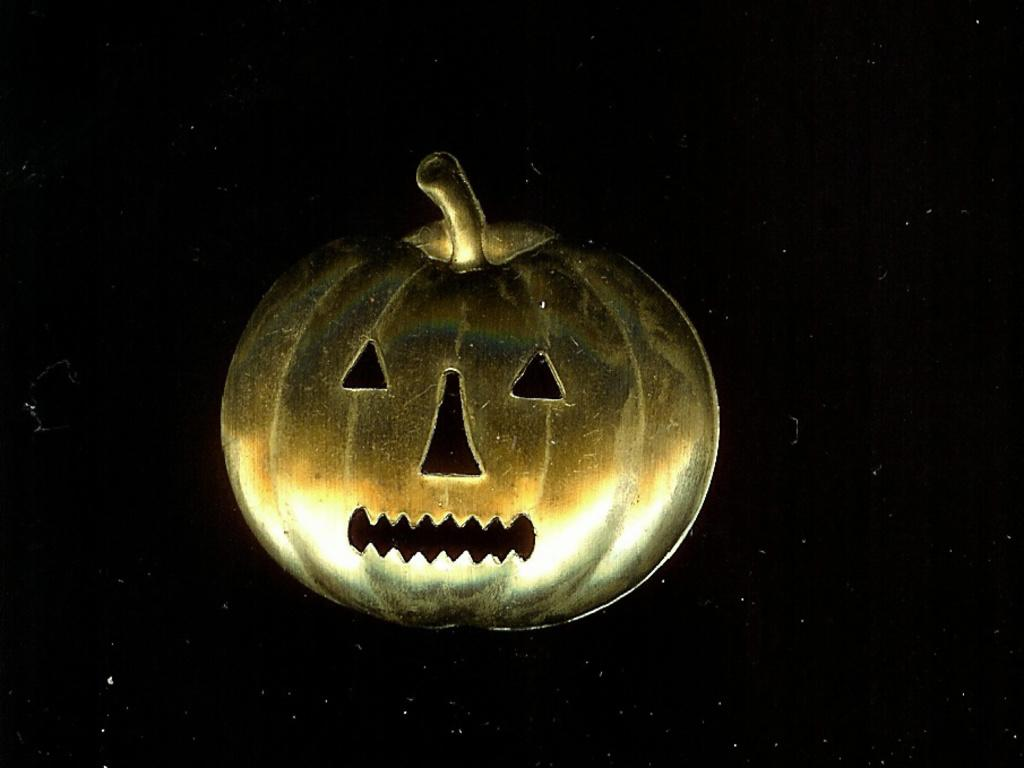What is the main subject of the image? There is a depiction of a pumpkin in the center of the image. Can you describe the appearance of the pumpkin? The provided facts do not include a description of the pumpkin's appearance. What might be the purpose of the image? The purpose of the image is not specified in the provided facts. What is the result of 2 + 2 in the image? There is no arithmetic or numerical information present in the image, so it is not possible to answer that question. 